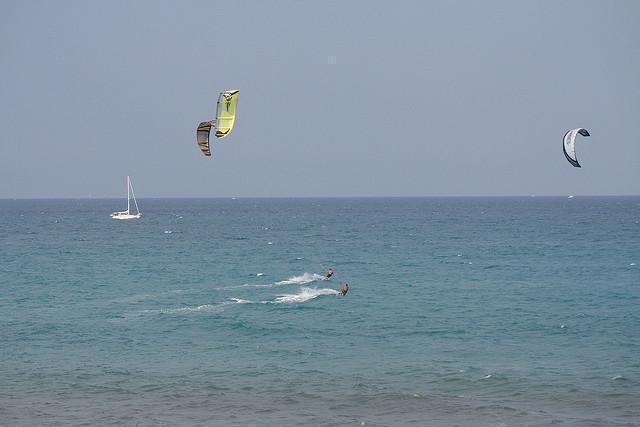What sport are the two people in the water participating in?
Select the correct answer and articulate reasoning with the following format: 'Answer: answer
Rationale: rationale.'
Options: Surfing, sailing, swimming, para waterskiing. Answer: para waterskiing.
Rationale: The people are para waterskiing. 